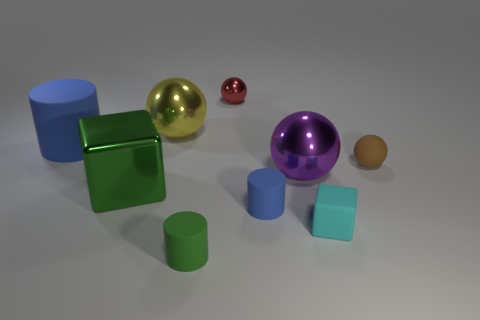Subtract all cylinders. How many objects are left? 6 Subtract all yellow matte spheres. Subtract all small cyan rubber things. How many objects are left? 8 Add 9 green rubber cylinders. How many green rubber cylinders are left? 10 Add 7 large brown matte objects. How many large brown matte objects exist? 7 Subtract 1 green cylinders. How many objects are left? 8 